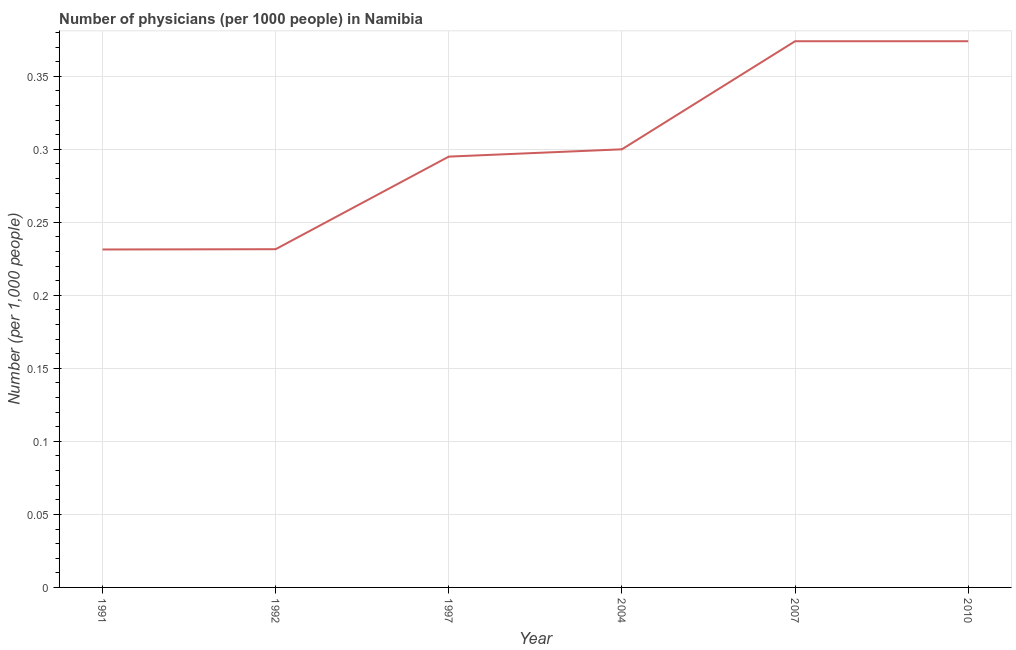What is the number of physicians in 1991?
Your answer should be very brief. 0.23. Across all years, what is the maximum number of physicians?
Your answer should be very brief. 0.37. Across all years, what is the minimum number of physicians?
Provide a short and direct response. 0.23. What is the sum of the number of physicians?
Provide a succinct answer. 1.81. What is the difference between the number of physicians in 1991 and 2007?
Your answer should be very brief. -0.14. What is the average number of physicians per year?
Your answer should be compact. 0.3. What is the median number of physicians?
Your answer should be compact. 0.3. Do a majority of the years between 2004 and 1991 (inclusive) have number of physicians greater than 0.37000000000000005 ?
Keep it short and to the point. Yes. What is the ratio of the number of physicians in 2004 to that in 2010?
Keep it short and to the point. 0.8. What is the difference between the highest and the second highest number of physicians?
Offer a terse response. 0. What is the difference between the highest and the lowest number of physicians?
Offer a very short reply. 0.14. Does the number of physicians monotonically increase over the years?
Ensure brevity in your answer.  No. What is the difference between two consecutive major ticks on the Y-axis?
Offer a very short reply. 0.05. Are the values on the major ticks of Y-axis written in scientific E-notation?
Keep it short and to the point. No. Does the graph contain any zero values?
Ensure brevity in your answer.  No. What is the title of the graph?
Provide a short and direct response. Number of physicians (per 1000 people) in Namibia. What is the label or title of the X-axis?
Offer a very short reply. Year. What is the label or title of the Y-axis?
Ensure brevity in your answer.  Number (per 1,0 people). What is the Number (per 1,000 people) in 1991?
Your response must be concise. 0.23. What is the Number (per 1,000 people) of 1992?
Your answer should be compact. 0.23. What is the Number (per 1,000 people) of 1997?
Your answer should be very brief. 0.29. What is the Number (per 1,000 people) of 2007?
Offer a terse response. 0.37. What is the Number (per 1,000 people) in 2010?
Provide a short and direct response. 0.37. What is the difference between the Number (per 1,000 people) in 1991 and 1992?
Your answer should be compact. -0. What is the difference between the Number (per 1,000 people) in 1991 and 1997?
Provide a succinct answer. -0.06. What is the difference between the Number (per 1,000 people) in 1991 and 2004?
Provide a short and direct response. -0.07. What is the difference between the Number (per 1,000 people) in 1991 and 2007?
Ensure brevity in your answer.  -0.14. What is the difference between the Number (per 1,000 people) in 1991 and 2010?
Give a very brief answer. -0.14. What is the difference between the Number (per 1,000 people) in 1992 and 1997?
Make the answer very short. -0.06. What is the difference between the Number (per 1,000 people) in 1992 and 2004?
Provide a short and direct response. -0.07. What is the difference between the Number (per 1,000 people) in 1992 and 2007?
Your answer should be compact. -0.14. What is the difference between the Number (per 1,000 people) in 1992 and 2010?
Provide a succinct answer. -0.14. What is the difference between the Number (per 1,000 people) in 1997 and 2004?
Your answer should be very brief. -0.01. What is the difference between the Number (per 1,000 people) in 1997 and 2007?
Provide a succinct answer. -0.08. What is the difference between the Number (per 1,000 people) in 1997 and 2010?
Your answer should be very brief. -0.08. What is the difference between the Number (per 1,000 people) in 2004 and 2007?
Offer a very short reply. -0.07. What is the difference between the Number (per 1,000 people) in 2004 and 2010?
Give a very brief answer. -0.07. What is the ratio of the Number (per 1,000 people) in 1991 to that in 1997?
Provide a short and direct response. 0.78. What is the ratio of the Number (per 1,000 people) in 1991 to that in 2004?
Offer a terse response. 0.77. What is the ratio of the Number (per 1,000 people) in 1991 to that in 2007?
Provide a succinct answer. 0.62. What is the ratio of the Number (per 1,000 people) in 1991 to that in 2010?
Give a very brief answer. 0.62. What is the ratio of the Number (per 1,000 people) in 1992 to that in 1997?
Your response must be concise. 0.79. What is the ratio of the Number (per 1,000 people) in 1992 to that in 2004?
Provide a succinct answer. 0.77. What is the ratio of the Number (per 1,000 people) in 1992 to that in 2007?
Provide a succinct answer. 0.62. What is the ratio of the Number (per 1,000 people) in 1992 to that in 2010?
Keep it short and to the point. 0.62. What is the ratio of the Number (per 1,000 people) in 1997 to that in 2007?
Ensure brevity in your answer.  0.79. What is the ratio of the Number (per 1,000 people) in 1997 to that in 2010?
Offer a very short reply. 0.79. What is the ratio of the Number (per 1,000 people) in 2004 to that in 2007?
Provide a succinct answer. 0.8. What is the ratio of the Number (per 1,000 people) in 2004 to that in 2010?
Make the answer very short. 0.8. What is the ratio of the Number (per 1,000 people) in 2007 to that in 2010?
Ensure brevity in your answer.  1. 